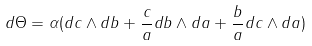<formula> <loc_0><loc_0><loc_500><loc_500>d \Theta = \alpha ( d c \wedge d b + \frac { c } { a } d b \wedge d a + \frac { b } { a } d c \wedge d a )</formula> 